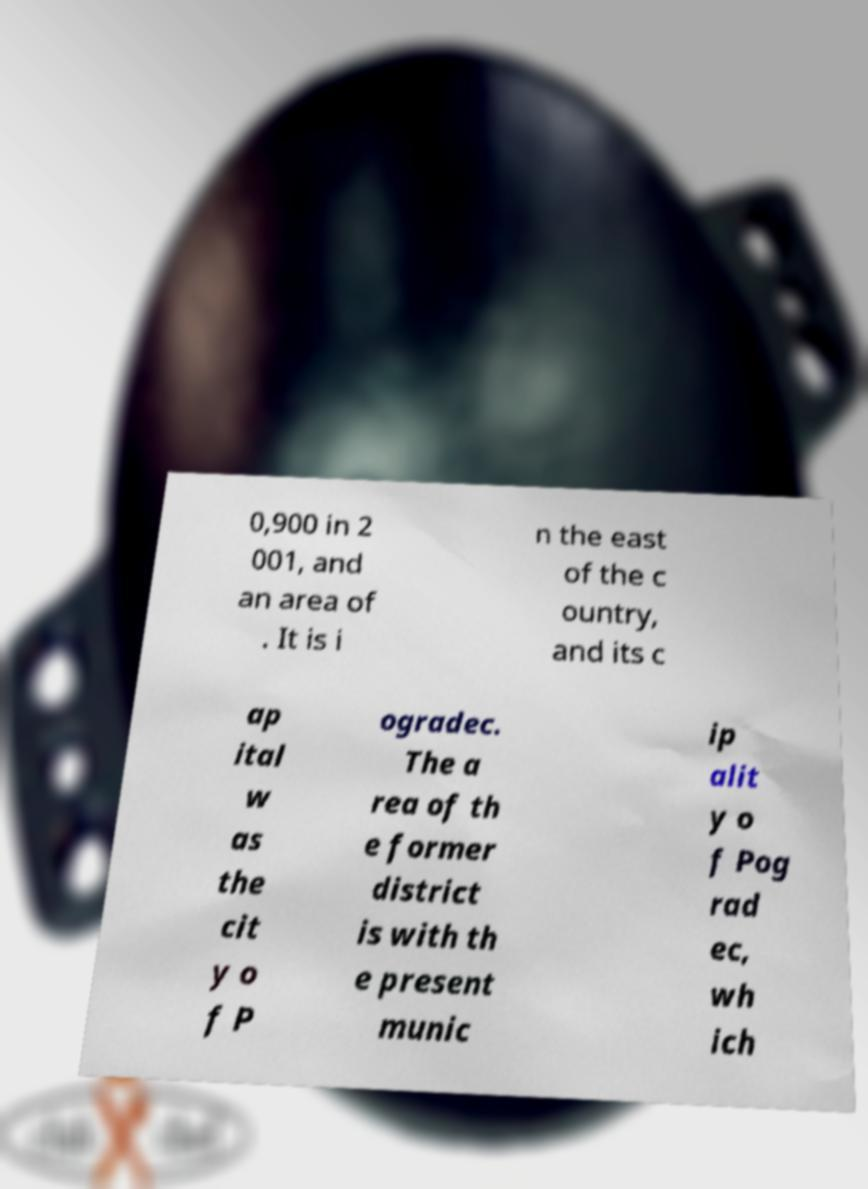I need the written content from this picture converted into text. Can you do that? 0,900 in 2 001, and an area of . It is i n the east of the c ountry, and its c ap ital w as the cit y o f P ogradec. The a rea of th e former district is with th e present munic ip alit y o f Pog rad ec, wh ich 